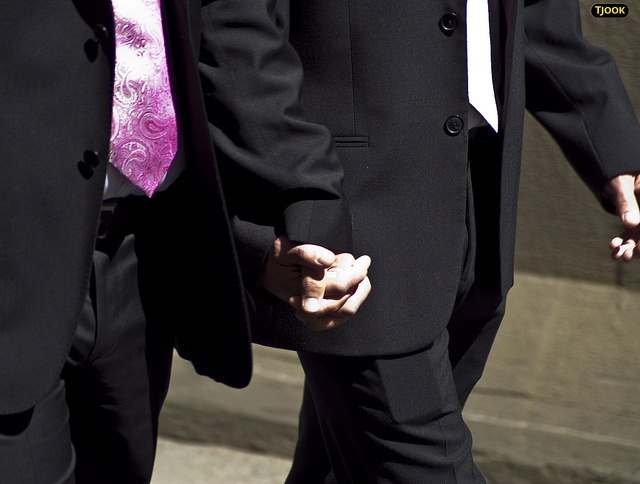Describe the objects in this image and their specific colors. I can see people in black, white, magenta, and gray tones, people in black, white, and gray tones, tie in black, lavender, magenta, and violet tones, and tie in black, white, navy, darkgray, and purple tones in this image. 